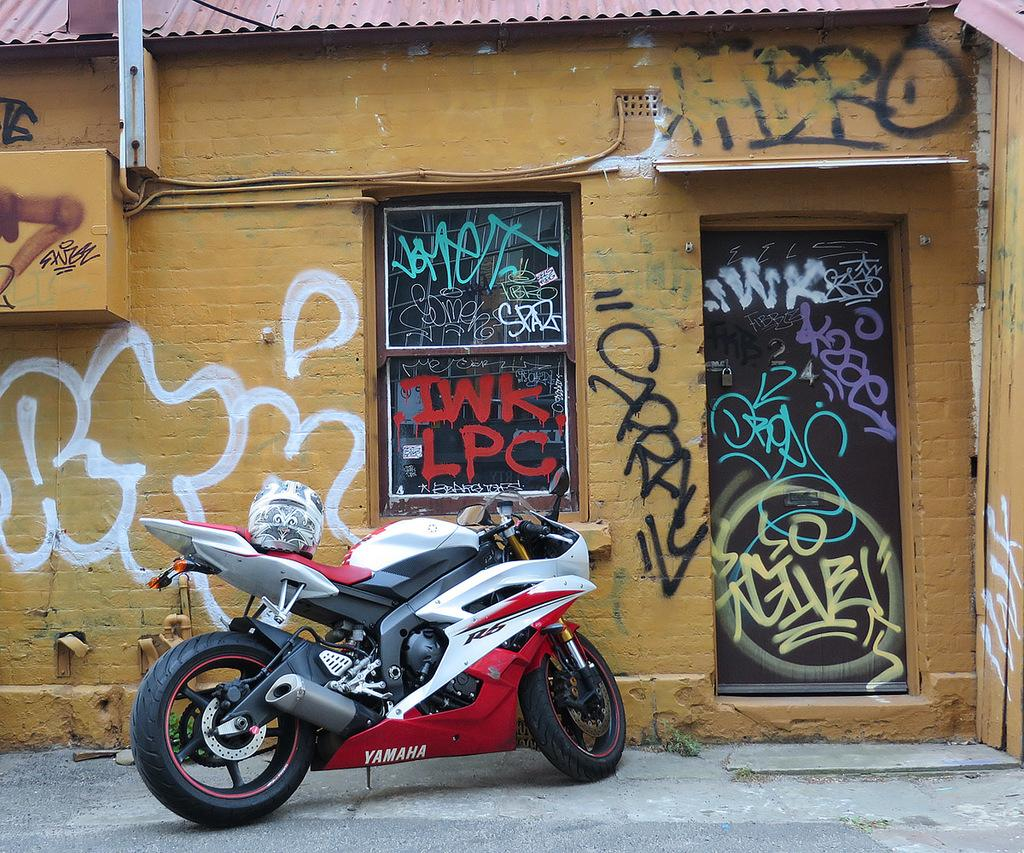What is the main subject in the center of the image? There is a bike in the center of the image. What can be seen in the background of the image? There is a house in the background of the image. Are there any architectural features visible in the image? Yes, there is a door and a window in the image. What type of cap is being worn by the bike in the image? There is no cap present in the image, as the subject is a bike and not a person. 